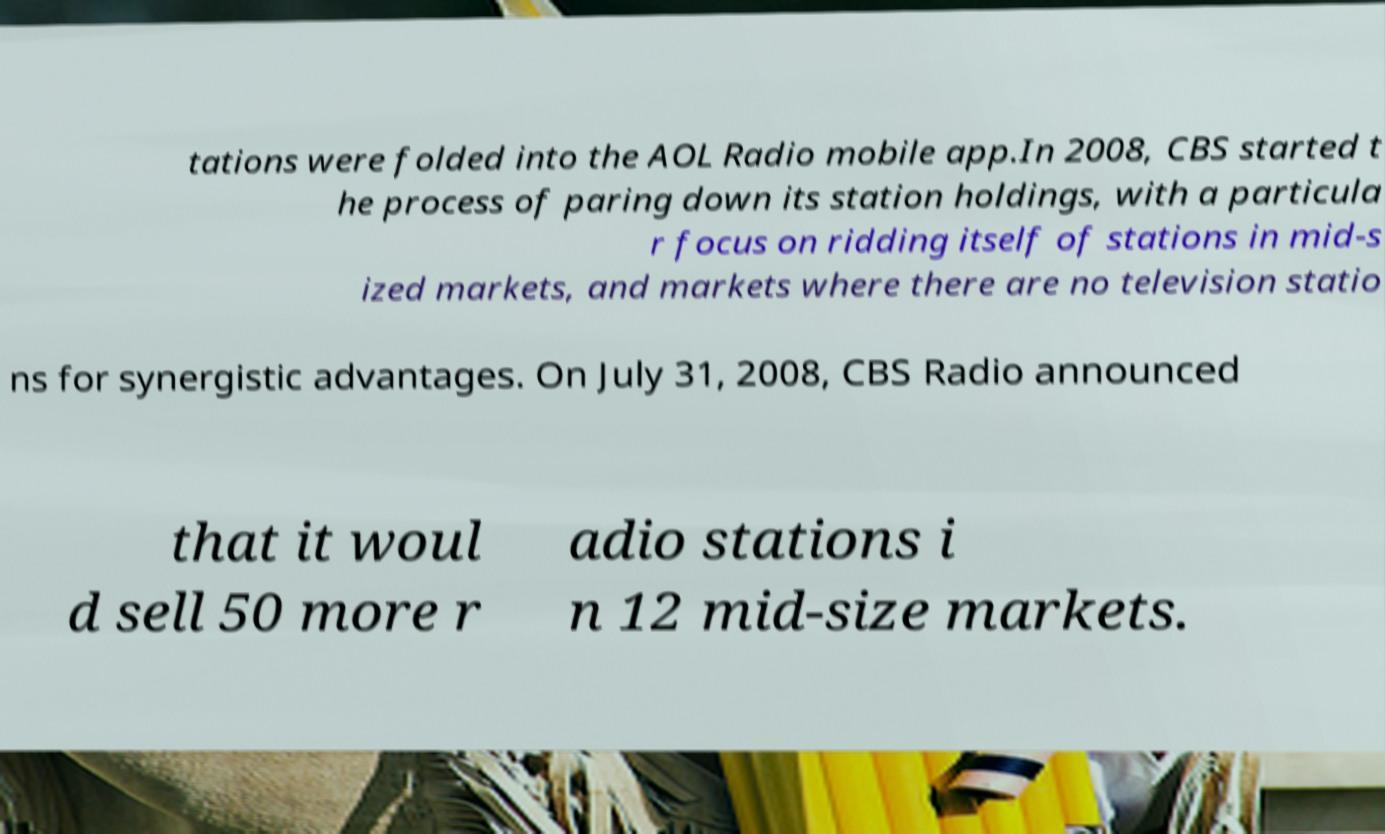Please identify and transcribe the text found in this image. tations were folded into the AOL Radio mobile app.In 2008, CBS started t he process of paring down its station holdings, with a particula r focus on ridding itself of stations in mid-s ized markets, and markets where there are no television statio ns for synergistic advantages. On July 31, 2008, CBS Radio announced that it woul d sell 50 more r adio stations i n 12 mid-size markets. 